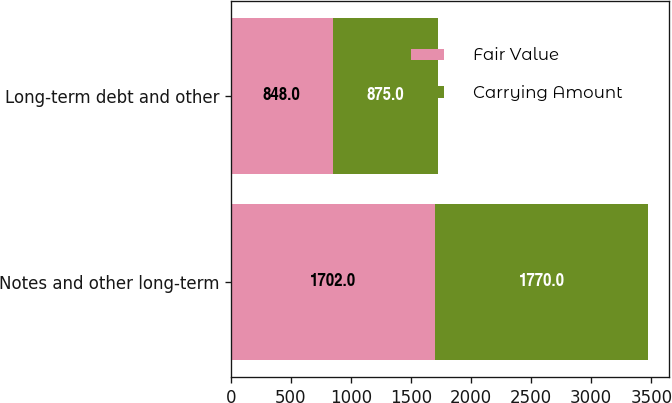Convert chart to OTSL. <chart><loc_0><loc_0><loc_500><loc_500><stacked_bar_chart><ecel><fcel>Notes and other long-term<fcel>Long-term debt and other<nl><fcel>Fair Value<fcel>1702<fcel>848<nl><fcel>Carrying Amount<fcel>1770<fcel>875<nl></chart> 